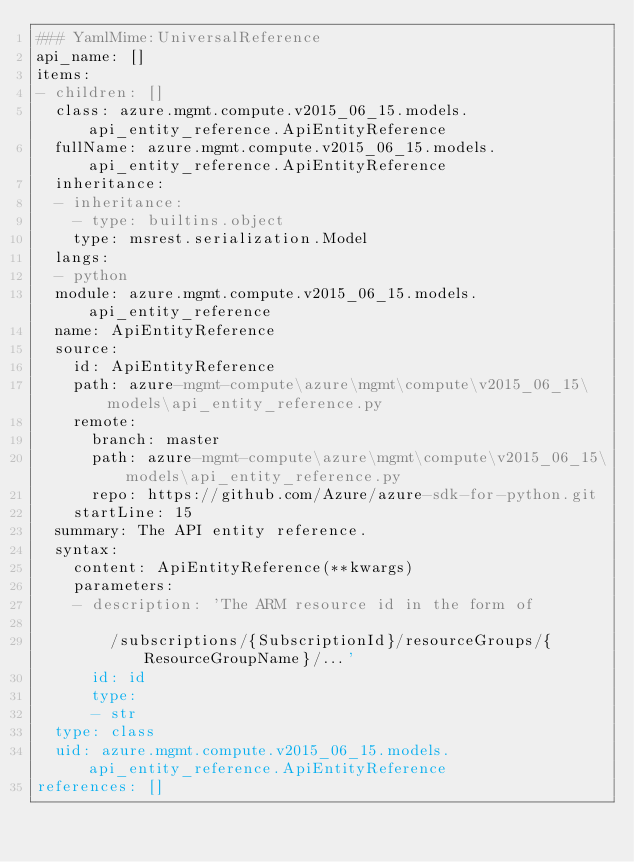<code> <loc_0><loc_0><loc_500><loc_500><_YAML_>### YamlMime:UniversalReference
api_name: []
items:
- children: []
  class: azure.mgmt.compute.v2015_06_15.models.api_entity_reference.ApiEntityReference
  fullName: azure.mgmt.compute.v2015_06_15.models.api_entity_reference.ApiEntityReference
  inheritance:
  - inheritance:
    - type: builtins.object
    type: msrest.serialization.Model
  langs:
  - python
  module: azure.mgmt.compute.v2015_06_15.models.api_entity_reference
  name: ApiEntityReference
  source:
    id: ApiEntityReference
    path: azure-mgmt-compute\azure\mgmt\compute\v2015_06_15\models\api_entity_reference.py
    remote:
      branch: master
      path: azure-mgmt-compute\azure\mgmt\compute\v2015_06_15\models\api_entity_reference.py
      repo: https://github.com/Azure/azure-sdk-for-python.git
    startLine: 15
  summary: The API entity reference.
  syntax:
    content: ApiEntityReference(**kwargs)
    parameters:
    - description: 'The ARM resource id in the form of

        /subscriptions/{SubscriptionId}/resourceGroups/{ResourceGroupName}/...'
      id: id
      type:
      - str
  type: class
  uid: azure.mgmt.compute.v2015_06_15.models.api_entity_reference.ApiEntityReference
references: []
</code> 